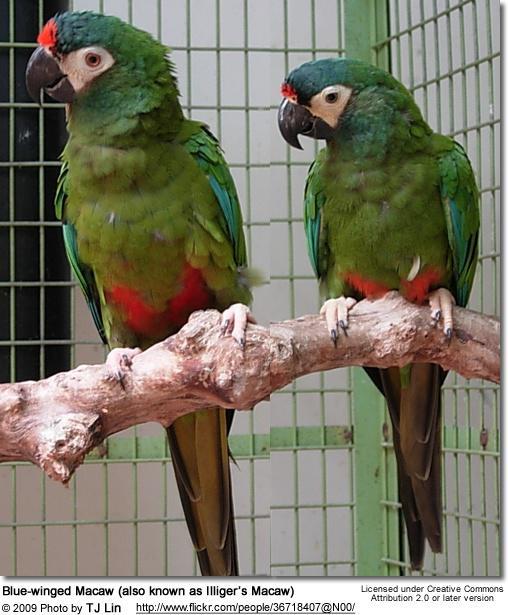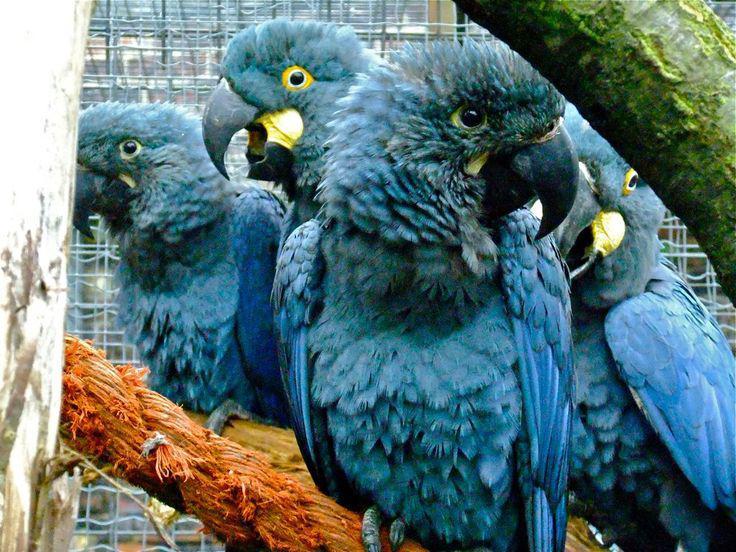The first image is the image on the left, the second image is the image on the right. For the images displayed, is the sentence "An image shows exactly one parrot, which is blue." factually correct? Answer yes or no. No. The first image is the image on the left, the second image is the image on the right. Evaluate the accuracy of this statement regarding the images: "In one image, a single blue parrot is sitting on a perch.". Is it true? Answer yes or no. No. 